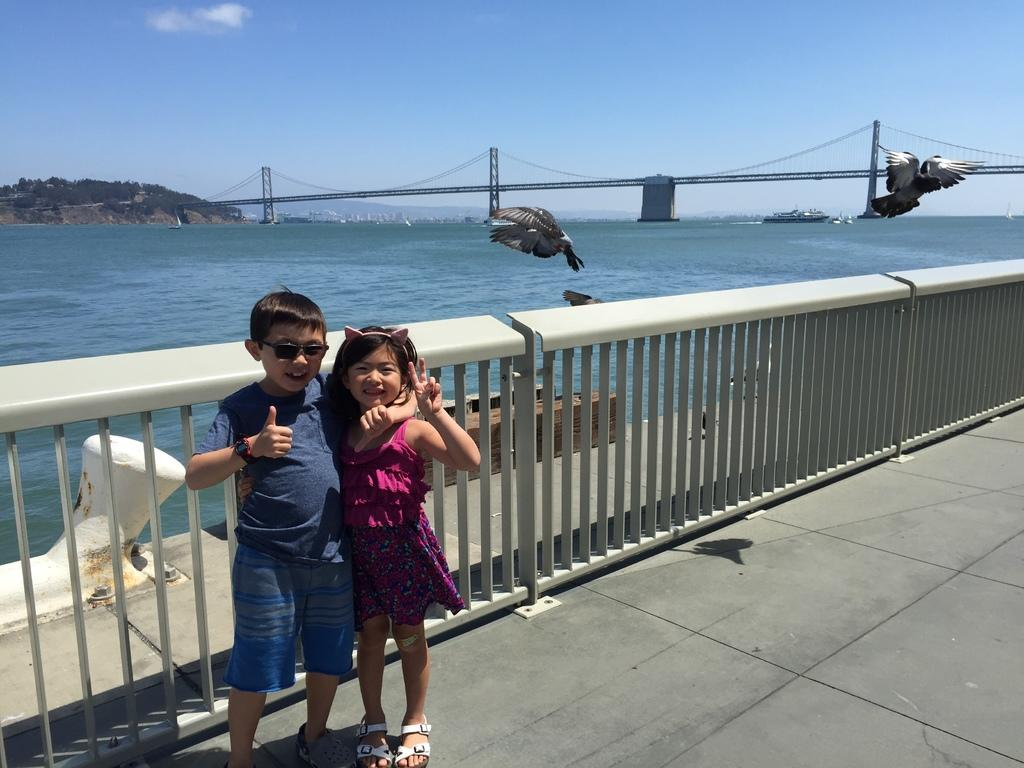How many children are in the image? There are two children in the image. What are the children doing in the image? The children are posing for a camera. What can be seen in the background of the image? There is a road, a fence, water, a ship, birds, a bridge, trees, and the sky visible in the background. What type of button can be seen on the hospital in the image? There is no hospital present in the image, and therefore no button can be seen on it. 